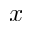<formula> <loc_0><loc_0><loc_500><loc_500>x</formula> 